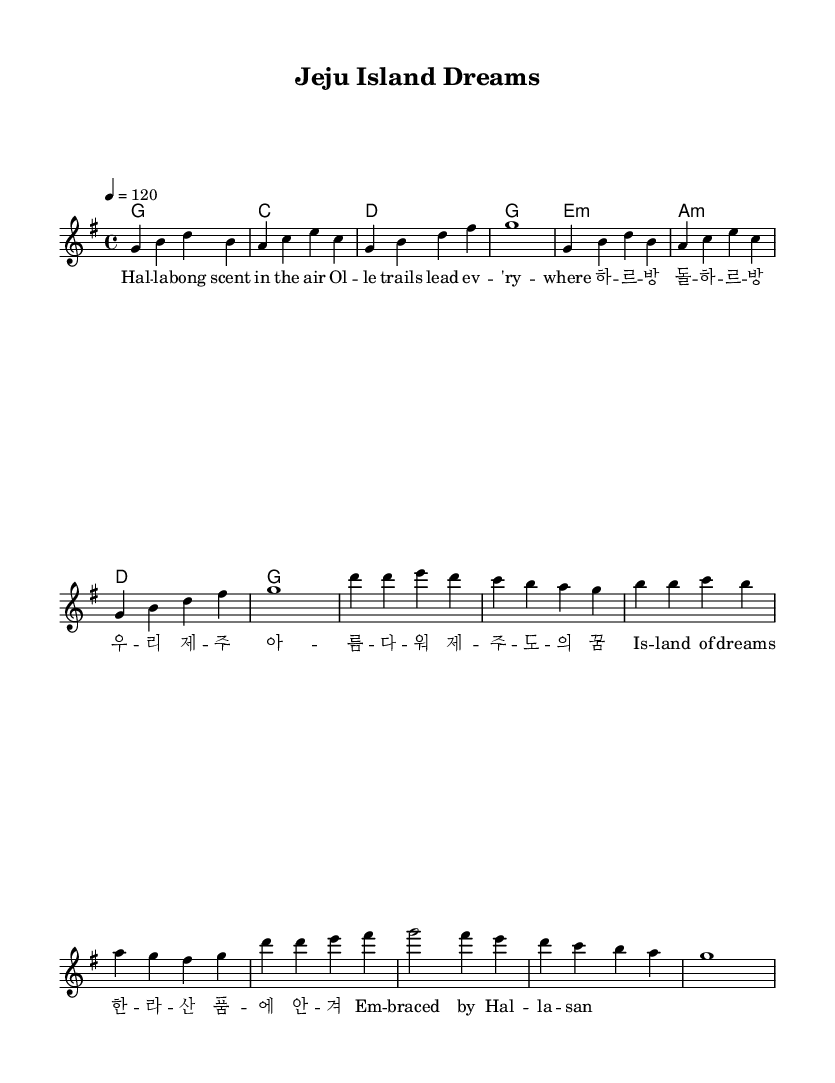What is the key signature of this music? The key signature shown in the music sheet is G major, which has one sharp (F#). You can identify the key signature at the beginning of the staff just after the clef.
Answer: G major What is the time signature of this music? The time signature is 4/4, indicated at the beginning of the score. This means there are four beats in a measure, and the quarter note receives one beat.
Answer: 4/4 What is the tempo marking of this piece? The tempo marking is indicated as 4 = 120, which suggests that the quarter note gets 120 beats per minute. This is typically seen above the staff or in the header.
Answer: 120 How many measures are in the melody section? The melody section consists of 16 measures, as counted visually by looking at the bar lines in the notation. Each group of four quarter notes typically represents one measure.
Answer: 16 What is the lyrical theme of the chorus? The chorus lyrics reference "Isle of dreams" and "Embraced by Hal-la-san," highlighting the dreams and natural beauty of Jeju Island. By analyzing the text associated with the melody, we can infer the theme.
Answer: Isle of dreams What dialect is reflected in the lyrics of this piece? The lyrics contain the phrase "하르방 돌하르방," which is a local Jeju dialect term for "grandfather" and is a cultural reference unique to Jeju Island, reflecting the regional identity in the song's lyrics.
Answer: Jeju dialect What musical form is used in this K-pop track? The piece employs a simple verse-chorus structure common in K-pop, where the distinct sections alternate, allowing a clear distinction between the story told in the verses and the emotional high point in the chorus.
Answer: Verse-chorus 